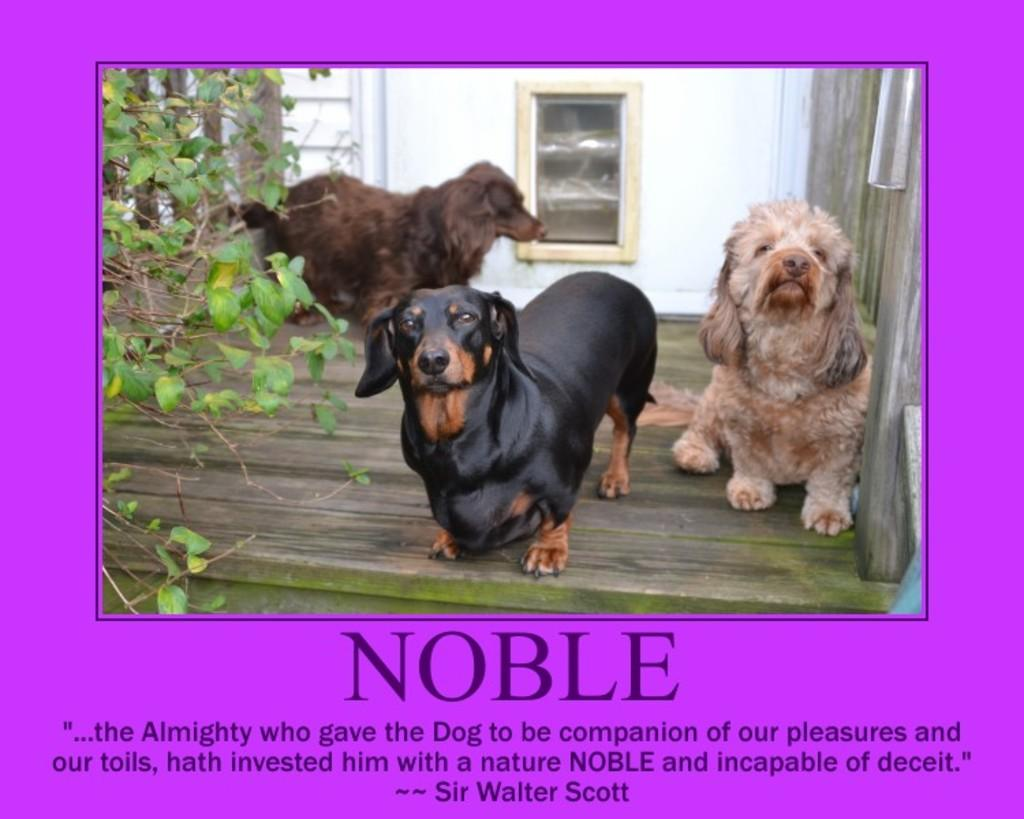What is the main subject of the poster in the image? The poster contains images of dogs and plants. What other elements can be seen on the poster? There is a window depicted on the poster, and there is text written at the bottom of the poster. What type of advice is given by the dogs in the image? There are no dogs giving advice in the image; they are depicted as images on the poster. 